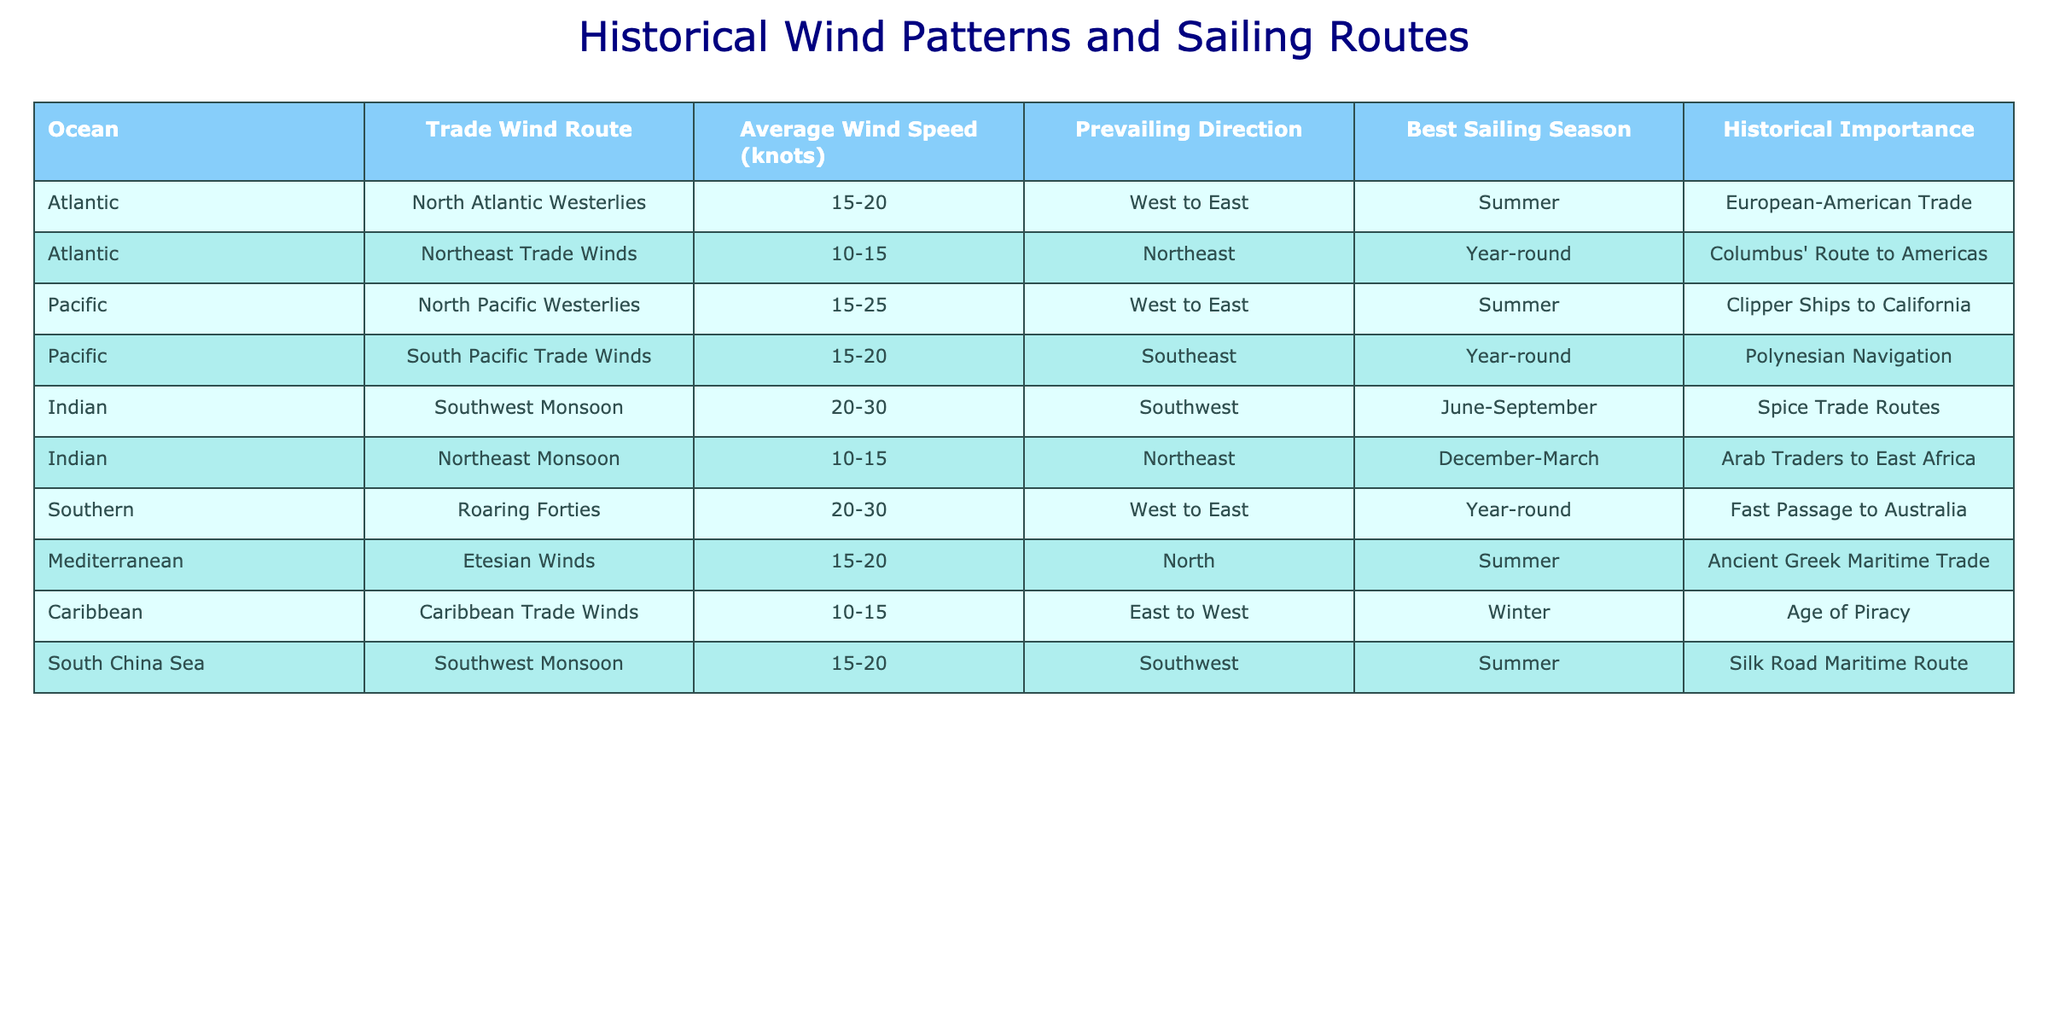What are the average wind speeds in the Indian Ocean? The Indian Ocean has two entries: the Southwest Monsoon (20-30 knots) and Northeast Monsoon (10-15 knots). Calculating the average speed involves considering the midpoints of these ranges: (25 + 12.5) / 2 = 18.75 knots.
Answer: 18.75 knots Which ocean has the best sailing season year-round? The table lists the Northeast Trade Winds and the South Pacific Trade Winds in the Atlantic and Pacific Oceans, respectively, as having a best sailing season year-round.
Answer: Atlantic and Pacific Oceans What direction do the Roaring Forties winds predominantly blow? The Roaring Forties' prevailing direction is specified in the table as "West to East."
Answer: West to East How many trade routes have an average wind speed of 15 knots or more? By reviewing the table, I count all sailing routes with speeds above 15 knots: North Atlantic Westerlies, North Pacific Westerlies, South Pacific Trade Winds, Southwest Monsoon, Roaring Forties, Etesian Winds, and Southwest Monsoon of the South China Sea. That gives us a total of 7 routes.
Answer: 7 Are the Caribbean Trade Winds associated with the Age of Piracy? Yes, the table mentions that the Caribbean Trade Winds are related to the Age of Piracy, which confirms the fact.
Answer: Yes Which ocean has the highest average wind speeds in its trade routes? Analyzing the average wind speeds, the Indian Ocean's Southwest Monsoon (20-30 knots) stands out with the highest minimum of 20 knots; thus, it has the highest average wind speeds compared to other oceans.
Answer: Indian Ocean Which two routes have the same average wind speed? The table lists the Northeast Trade Winds (10-15 knots) and the Northeast Monsoon (10-15 knots). Both have the same average wind speed range of 15 knots.
Answer: Northeast Trade Winds and Northeast Monsoon What was the historical importance of the South Pacific Trade Winds? The South Pacific Trade Winds are historically important for Polynesian navigation, as indicated in the table.
Answer: Polynesian navigation Which sailing route operates with the strongest winds and what is their range? The strongest winds are associated with the Indian Ocean's Southwest Monsoon, which has an average wind speed range of 20-30 knots.
Answer: 20-30 knots In which season is the best time for sailing along the Northeast Trade Winds? The table notes that the best sailing season for the Northeast Trade Winds is year-round, allowing passage in any season.
Answer: Year-round 